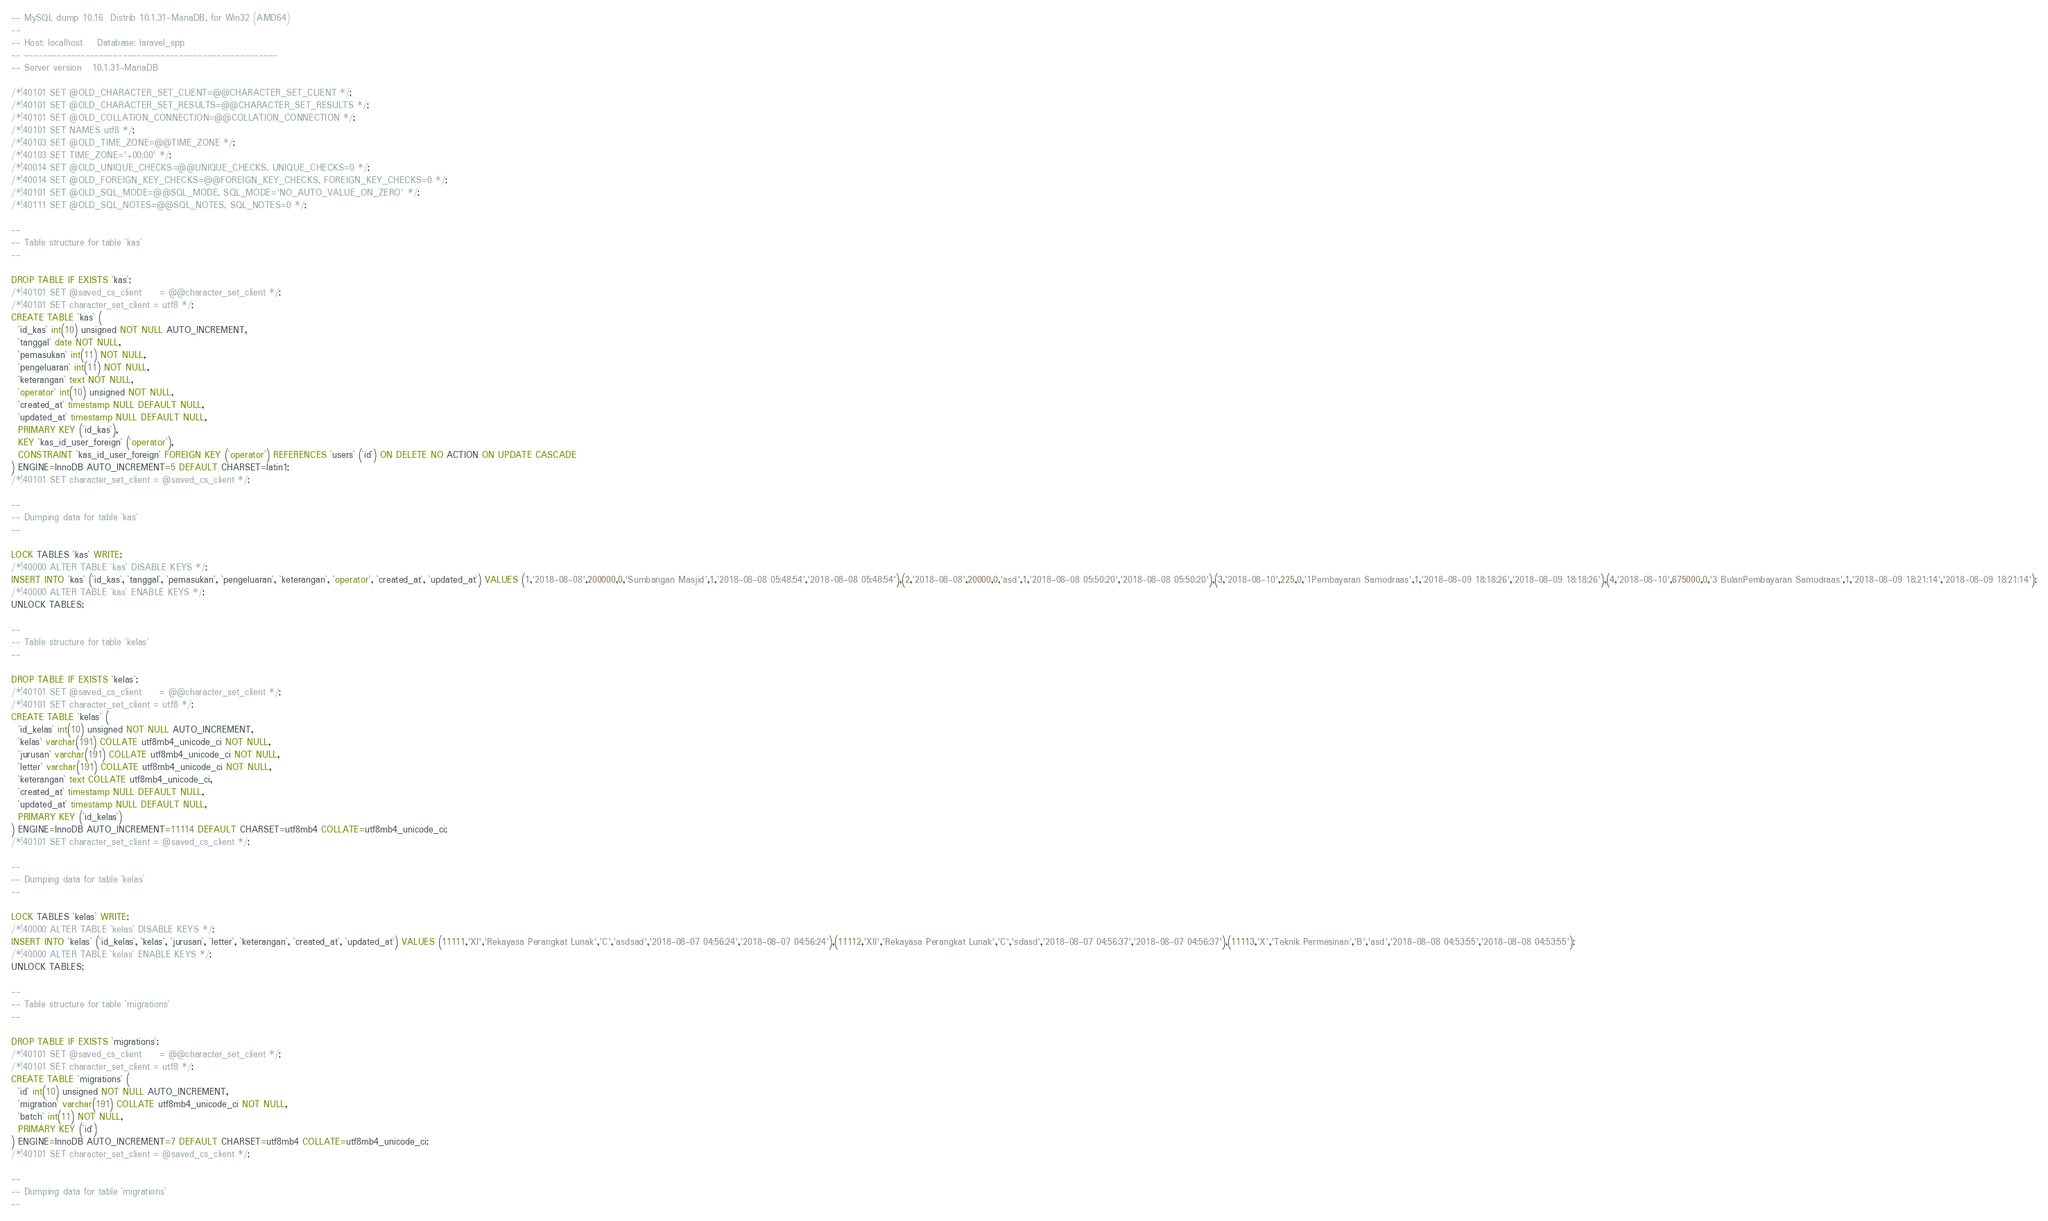Convert code to text. <code><loc_0><loc_0><loc_500><loc_500><_SQL_>-- MySQL dump 10.16  Distrib 10.1.31-MariaDB, for Win32 (AMD64)
--
-- Host: localhost    Database: laravel_spp
-- ------------------------------------------------------
-- Server version	10.1.31-MariaDB

/*!40101 SET @OLD_CHARACTER_SET_CLIENT=@@CHARACTER_SET_CLIENT */;
/*!40101 SET @OLD_CHARACTER_SET_RESULTS=@@CHARACTER_SET_RESULTS */;
/*!40101 SET @OLD_COLLATION_CONNECTION=@@COLLATION_CONNECTION */;
/*!40101 SET NAMES utf8 */;
/*!40103 SET @OLD_TIME_ZONE=@@TIME_ZONE */;
/*!40103 SET TIME_ZONE='+00:00' */;
/*!40014 SET @OLD_UNIQUE_CHECKS=@@UNIQUE_CHECKS, UNIQUE_CHECKS=0 */;
/*!40014 SET @OLD_FOREIGN_KEY_CHECKS=@@FOREIGN_KEY_CHECKS, FOREIGN_KEY_CHECKS=0 */;
/*!40101 SET @OLD_SQL_MODE=@@SQL_MODE, SQL_MODE='NO_AUTO_VALUE_ON_ZERO' */;
/*!40111 SET @OLD_SQL_NOTES=@@SQL_NOTES, SQL_NOTES=0 */;

--
-- Table structure for table `kas`
--

DROP TABLE IF EXISTS `kas`;
/*!40101 SET @saved_cs_client     = @@character_set_client */;
/*!40101 SET character_set_client = utf8 */;
CREATE TABLE `kas` (
  `id_kas` int(10) unsigned NOT NULL AUTO_INCREMENT,
  `tanggal` date NOT NULL,
  `pemasukan` int(11) NOT NULL,
  `pengeluaran` int(11) NOT NULL,
  `keterangan` text NOT NULL,
  `operator` int(10) unsigned NOT NULL,
  `created_at` timestamp NULL DEFAULT NULL,
  `updated_at` timestamp NULL DEFAULT NULL,
  PRIMARY KEY (`id_kas`),
  KEY `kas_id_user_foreign` (`operator`),
  CONSTRAINT `kas_id_user_foreign` FOREIGN KEY (`operator`) REFERENCES `users` (`id`) ON DELETE NO ACTION ON UPDATE CASCADE
) ENGINE=InnoDB AUTO_INCREMENT=5 DEFAULT CHARSET=latin1;
/*!40101 SET character_set_client = @saved_cs_client */;

--
-- Dumping data for table `kas`
--

LOCK TABLES `kas` WRITE;
/*!40000 ALTER TABLE `kas` DISABLE KEYS */;
INSERT INTO `kas` (`id_kas`, `tanggal`, `pemasukan`, `pengeluaran`, `keterangan`, `operator`, `created_at`, `updated_at`) VALUES (1,'2018-08-08',200000,0,'Sumbangan Masjid',1,'2018-08-08 05:48:54','2018-08-08 05:48:54'),(2,'2018-08-08',20000,0,'asd',1,'2018-08-08 05:50:20','2018-08-08 05:50:20'),(3,'2018-08-10',225,0,'1Pembayaran Samodraas',1,'2018-08-09 18:18:26','2018-08-09 18:18:26'),(4,'2018-08-10',675000,0,'3 BulanPembayaran Samodraas',1,'2018-08-09 18:21:14','2018-08-09 18:21:14');
/*!40000 ALTER TABLE `kas` ENABLE KEYS */;
UNLOCK TABLES;

--
-- Table structure for table `kelas`
--

DROP TABLE IF EXISTS `kelas`;
/*!40101 SET @saved_cs_client     = @@character_set_client */;
/*!40101 SET character_set_client = utf8 */;
CREATE TABLE `kelas` (
  `id_kelas` int(10) unsigned NOT NULL AUTO_INCREMENT,
  `kelas` varchar(191) COLLATE utf8mb4_unicode_ci NOT NULL,
  `jurusan` varchar(191) COLLATE utf8mb4_unicode_ci NOT NULL,
  `letter` varchar(191) COLLATE utf8mb4_unicode_ci NOT NULL,
  `keterangan` text COLLATE utf8mb4_unicode_ci,
  `created_at` timestamp NULL DEFAULT NULL,
  `updated_at` timestamp NULL DEFAULT NULL,
  PRIMARY KEY (`id_kelas`)
) ENGINE=InnoDB AUTO_INCREMENT=11114 DEFAULT CHARSET=utf8mb4 COLLATE=utf8mb4_unicode_ci;
/*!40101 SET character_set_client = @saved_cs_client */;

--
-- Dumping data for table `kelas`
--

LOCK TABLES `kelas` WRITE;
/*!40000 ALTER TABLE `kelas` DISABLE KEYS */;
INSERT INTO `kelas` (`id_kelas`, `kelas`, `jurusan`, `letter`, `keterangan`, `created_at`, `updated_at`) VALUES (11111,'XI','Rekayasa Perangkat Lunak','C','asdsad','2018-08-07 04:56:24','2018-08-07 04:56:24'),(11112,'XII','Rekayasa Perangkat Lunak','C','sdasd','2018-08-07 04:56:37','2018-08-07 04:56:37'),(11113,'X','Teknik Permesinan','B','asd','2018-08-08 04:53:55','2018-08-08 04:53:55');
/*!40000 ALTER TABLE `kelas` ENABLE KEYS */;
UNLOCK TABLES;

--
-- Table structure for table `migrations`
--

DROP TABLE IF EXISTS `migrations`;
/*!40101 SET @saved_cs_client     = @@character_set_client */;
/*!40101 SET character_set_client = utf8 */;
CREATE TABLE `migrations` (
  `id` int(10) unsigned NOT NULL AUTO_INCREMENT,
  `migration` varchar(191) COLLATE utf8mb4_unicode_ci NOT NULL,
  `batch` int(11) NOT NULL,
  PRIMARY KEY (`id`)
) ENGINE=InnoDB AUTO_INCREMENT=7 DEFAULT CHARSET=utf8mb4 COLLATE=utf8mb4_unicode_ci;
/*!40101 SET character_set_client = @saved_cs_client */;

--
-- Dumping data for table `migrations`
--
</code> 